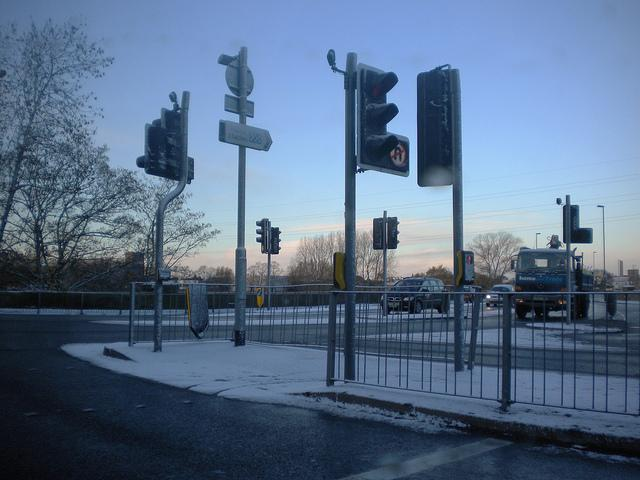What are drivers told is forbidden? Please explain your reasoning. u-turns. You can tell by the symbols on the sign as to what is not allowed at that street. 